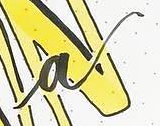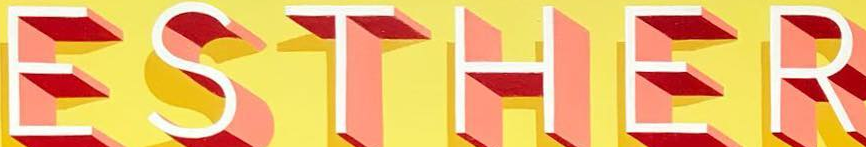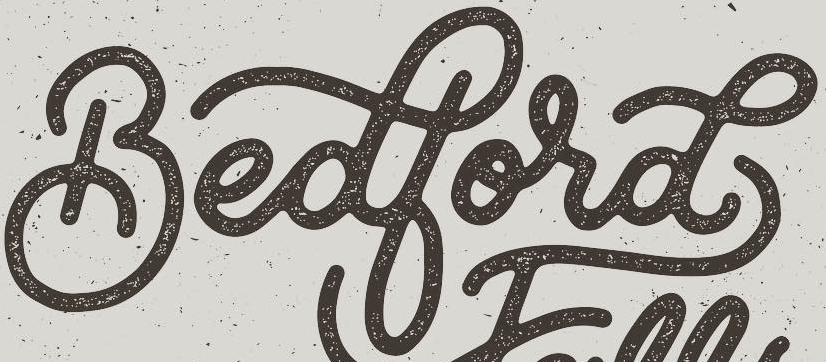What words are shown in these images in order, separated by a semicolon? a; ESTHER; Bedbord 